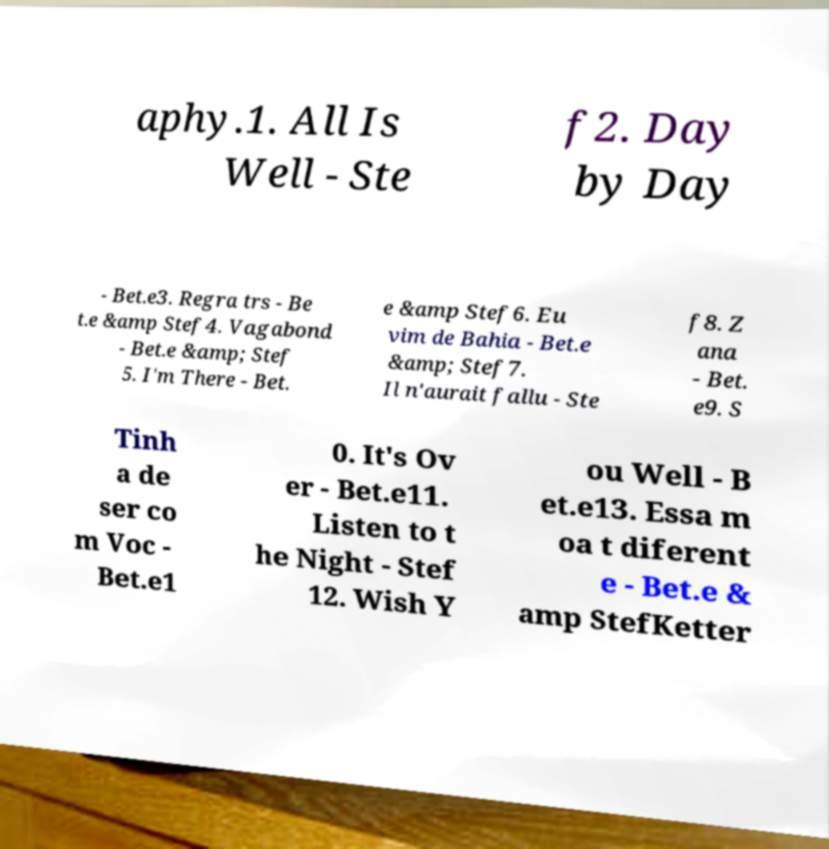Could you extract and type out the text from this image? aphy.1. All Is Well - Ste f2. Day by Day - Bet.e3. Regra trs - Be t.e &amp Stef4. Vagabond - Bet.e &amp; Stef 5. I'm There - Bet. e &amp Stef6. Eu vim de Bahia - Bet.e &amp; Stef7. Il n'aurait fallu - Ste f8. Z ana - Bet. e9. S Tinh a de ser co m Voc - Bet.e1 0. It's Ov er - Bet.e11. Listen to t he Night - Stef 12. Wish Y ou Well - B et.e13. Essa m oa t diferent e - Bet.e & amp StefKetter 